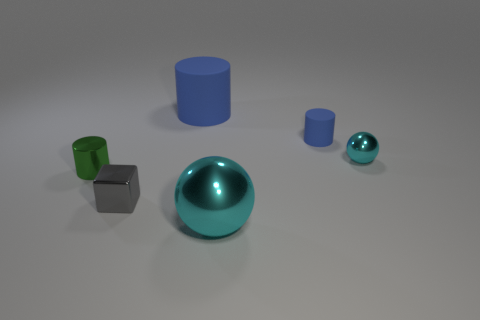Subtract all small green metal cylinders. How many cylinders are left? 2 Add 1 tiny things. How many objects exist? 7 Subtract all green cylinders. How many cylinders are left? 2 Subtract all balls. How many objects are left? 4 Subtract 2 balls. How many balls are left? 0 Subtract all red cylinders. Subtract all cyan blocks. How many cylinders are left? 3 Subtract all purple cubes. How many green cylinders are left? 1 Subtract all purple metallic cylinders. Subtract all small blue matte cylinders. How many objects are left? 5 Add 6 cyan metallic things. How many cyan metallic things are left? 8 Add 1 large cyan shiny objects. How many large cyan shiny objects exist? 2 